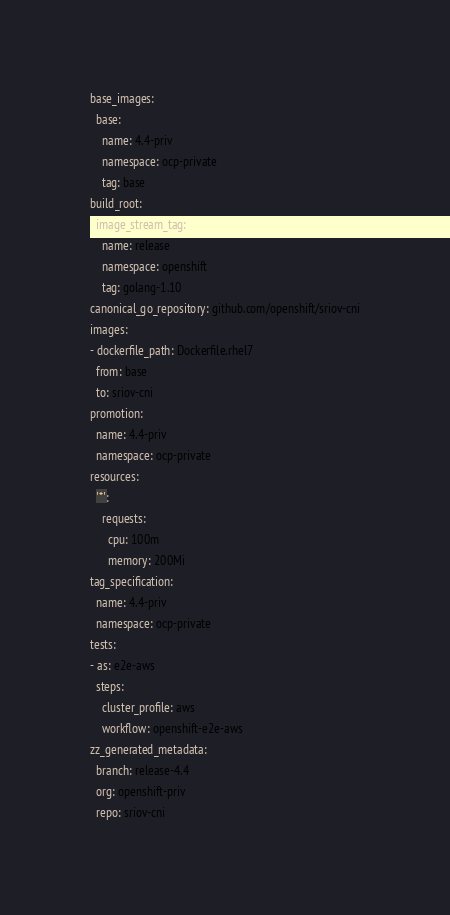<code> <loc_0><loc_0><loc_500><loc_500><_YAML_>base_images:
  base:
    name: 4.4-priv
    namespace: ocp-private
    tag: base
build_root:
  image_stream_tag:
    name: release
    namespace: openshift
    tag: golang-1.10
canonical_go_repository: github.com/openshift/sriov-cni
images:
- dockerfile_path: Dockerfile.rhel7
  from: base
  to: sriov-cni
promotion:
  name: 4.4-priv
  namespace: ocp-private
resources:
  '*':
    requests:
      cpu: 100m
      memory: 200Mi
tag_specification:
  name: 4.4-priv
  namespace: ocp-private
tests:
- as: e2e-aws
  steps:
    cluster_profile: aws
    workflow: openshift-e2e-aws
zz_generated_metadata:
  branch: release-4.4
  org: openshift-priv
  repo: sriov-cni
</code> 